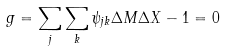Convert formula to latex. <formula><loc_0><loc_0><loc_500><loc_500>g = \sum _ { j } \sum _ { k } \psi _ { j k } \Delta M \Delta X - 1 = 0</formula> 